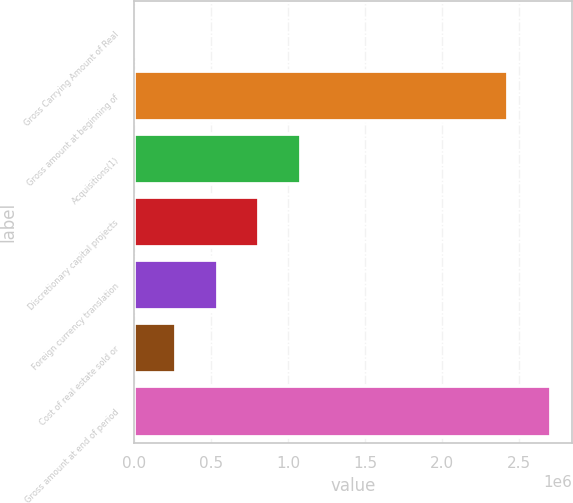Convert chart to OTSL. <chart><loc_0><loc_0><loc_500><loc_500><bar_chart><fcel>Gross Carrying Amount of Real<fcel>Gross amount at beginning of<fcel>Acquisitions(1)<fcel>Discretionary capital projects<fcel>Foreign currency translation<fcel>Cost of real estate sold or<fcel>Gross amount at end of period<nl><fcel>2017<fcel>2.42754e+06<fcel>1.08438e+06<fcel>813789<fcel>543199<fcel>272608<fcel>2.70792e+06<nl></chart> 